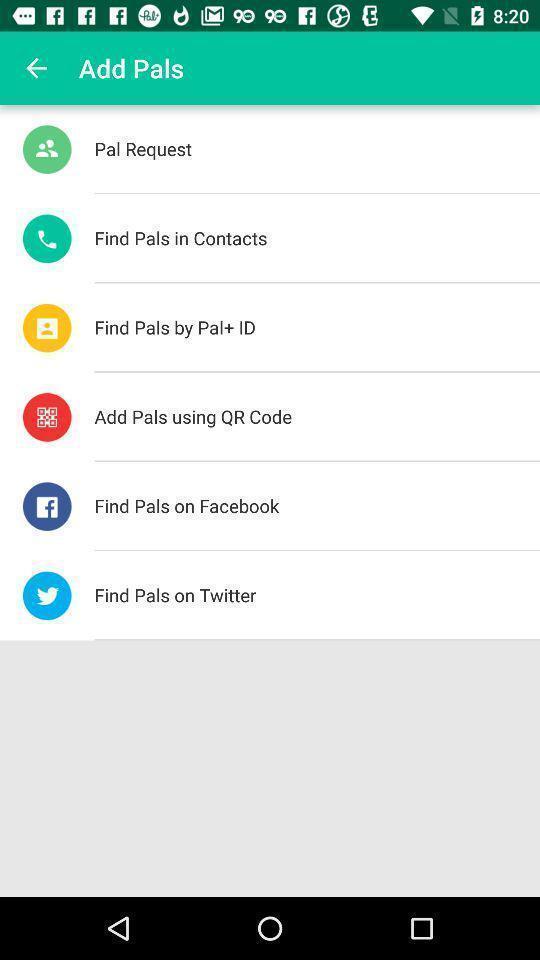Provide a description of this screenshot. Screen displaying the add pals. 